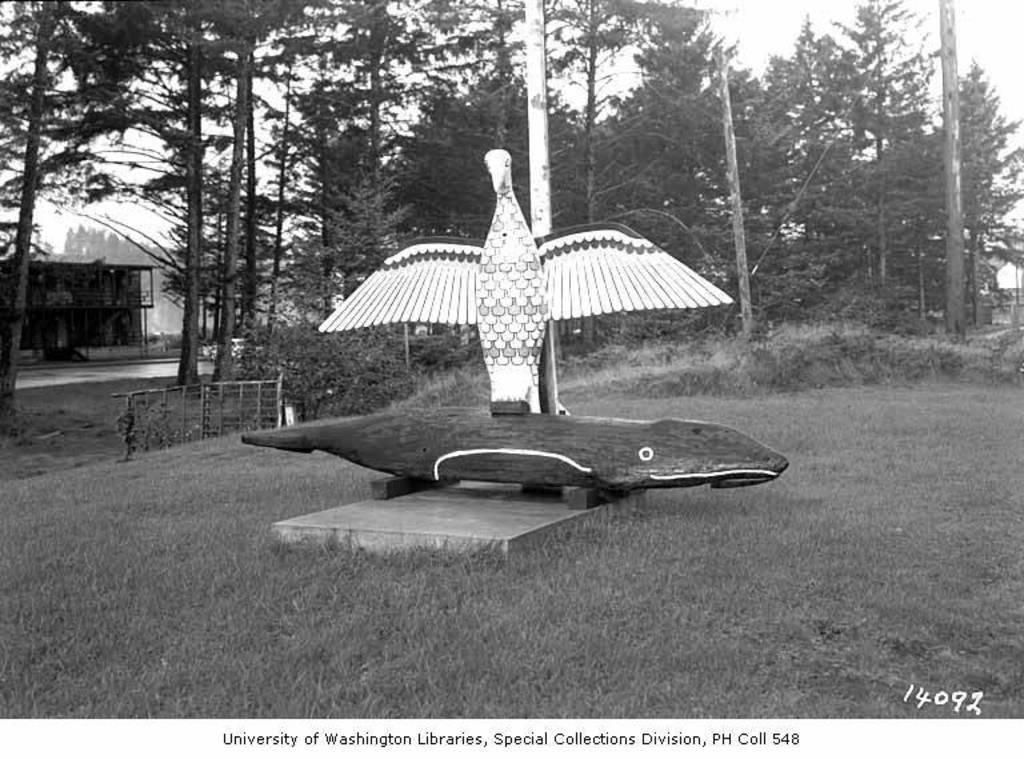Describe this image in one or two sentences. In this image there is a bird statue in the middle. In the background there are trees. At the bottom there is ground. It is the black and white image. On the left side it seems like a small house. In the middle there is an object which looks like a fish. 